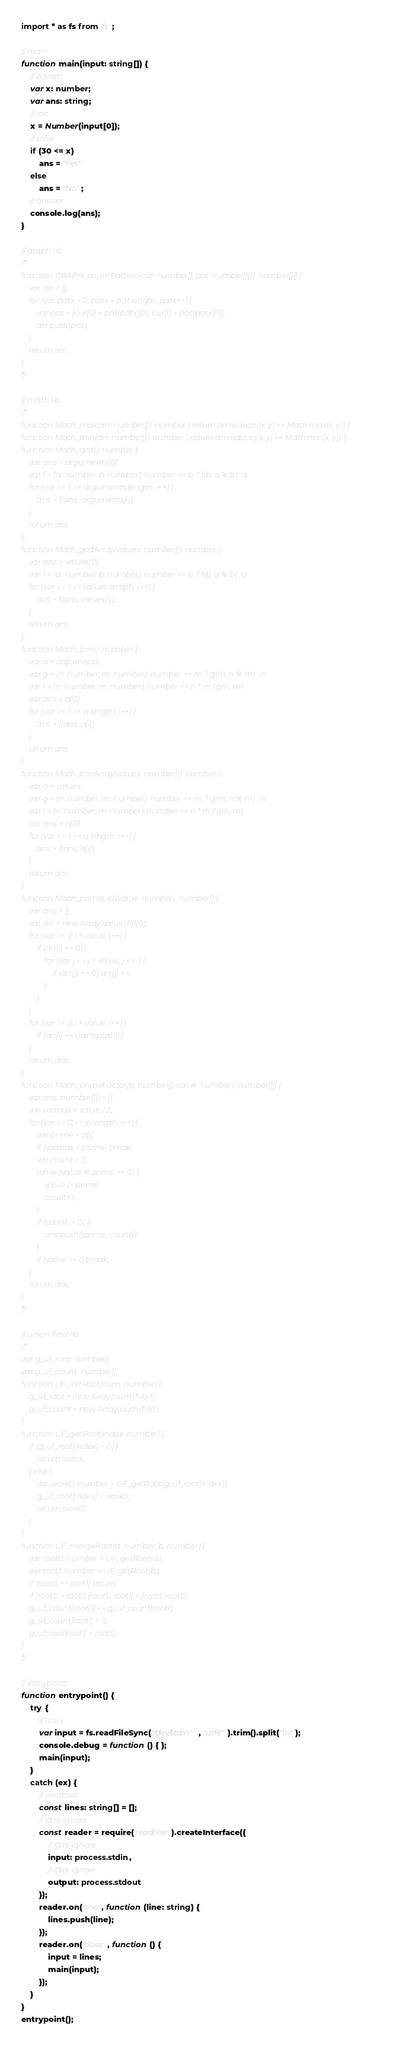<code> <loc_0><loc_0><loc_500><loc_500><_TypeScript_>import * as fs from 'fs';

// main
function main(input: string[]) {
    // param
    var x: number;
    var ans: string;
    // init
    x = Number(input[0]);
    // solve
    if (30 <= x)
        ans = "Yes"
    else
        ans = "No";
    // answer
    console.log(ans);
}

// graph lib
/*
function GRAPH_enumPattern(cur: number[], pat: number[][]): number[][] {
    var arr = [];
    for (var patx = 0; patx < pat.length; patx++) {
        var pos = [cur[0] + pat[patx][0], cur[1] + pat[patx][1]];
        arr.push(pos);
    }
    return arr;
}
*/

// math lib
/*
function Math_max(arr: number[]): number { return arr.reduce((x, y) => Math.max(x, y)); }
function Math_min(arr: number[]): number { return arr.reduce((x, y) => Math.min(x, y)); }
function Math_gcd(): number {
    var ans = arguments[0];
    var f = (a: number, b: number): number => b ? f(b, a % b) : a
    for (var i = 1; i < arguments.length; i++) {
        ans = f(ans, arguments[i]);
    }
    return ans
};
function Math_gcdArray(values: number[]): number {
    var ans = values[0];
    var f = (a: number, b: number): number => b ? f(b, a % b) : a
    for (var i = 1; i < values.length; i++) {
        ans = f(ans, values[i]);
    }
    return ans
};
function Math_lcm(): number {
    var a = arguments
    var g = (n: number, m: number): number => m ? g(m, n % m) : n
    var l = (n: number, m: number): number => n * m / g(n, m)
    var ans = a[0]
    for (var i = 1; i < a.length; i++) {
        ans = l(ans, a[i])
    }
    return ans
}
function Math_lcmArray(values: number[]): number {
    var a = values
    var g = (n: number, m: number): number => m ? g(m, n % m) : n
    var l = (n: number, m: number): number => n * m / g(n, m)
    var ans = a[0]
    for (var i = 1; i < a.length; i++) {
        ans = l(ans, a[i])
    }
    return ans
}
function Math_primeList(value: number): number[] {
    var ans = [];
    var arr = new Array(value).fill(0);
    for (var i = 2; i < value; i++) {
        if (arr[i] == 0) {
            for (var j = i; j < value; j += i) {
                if (arr[j] == 0) arr[j] = i;
            }
        }
    }
    for (var i = 2; i < value; i++) {
        if (arr[i] == i) ans.push(i);
    }
    return ans;
}
function Math_primeFactor(p: number[], value: number): number[][] {
    var ans: number[][] = [];
    var valmax = value / 2;;
    for (var i = 0; i < p.length; i++) {
        var prime = p[i];
        if (valmax < prime) break;
        var count = 0;
        while (value % prime == 0) {
            value /= prime;
            count++;
        }
        if (count != 0) {
            ans.push([prime, count]);
        }
        if (value == 1) break;
    }
    return ans;
}
*/

// union-find lib
/*
var g_uf_root: number[];
var g_uf_count: number[];
function UF_initRoot(num: number) {
    g_uf_root = new Array(num).fill(-1);
    g_uf_count = new Array(num).fill(1);
}
function UF_getRoot(index: number) {
    if (g_uf_root[index] < 0) {
        return index;
    } else {
        var work0: number = UF_getRoot(g_uf_root[index]);
        g_uf_root[index] = work0;
        return work0
    }
}
function UF_mergeRoot(a: number, b: number) {
    var root0: number = UF_getRoot(a);
    var root1: number = UF_getRoot(b);
    if (root0 == root1) return;
    if (root0 > root1) [root0, root1] = [root1, root0];
    g_uf_count[root0] += g_uf_count[root1];
    g_uf_count[root1] = 0;
    g_uf_root[root1] = root0;
}
*/

// entrypoint
function entrypoint() {
    try {
        // linux
        var input = fs.readFileSync("/dev/stdin", "utf8").trim().split("\n");
        console.debug = function () { };
        main(input);
    }
    catch (ex) {
        // windows
        const lines: string[] = [];
        // @ts-ignore
        const reader = require('readline').createInterface({
            // @ts-ignore
            input: process.stdin,
            // @ts-ignore
            output: process.stdout
        });
        reader.on('line', function (line: string) {
            lines.push(line);
        });
        reader.on('close', function () {
            input = lines;
            main(input);
        });
    }
}
entrypoint();
</code> 